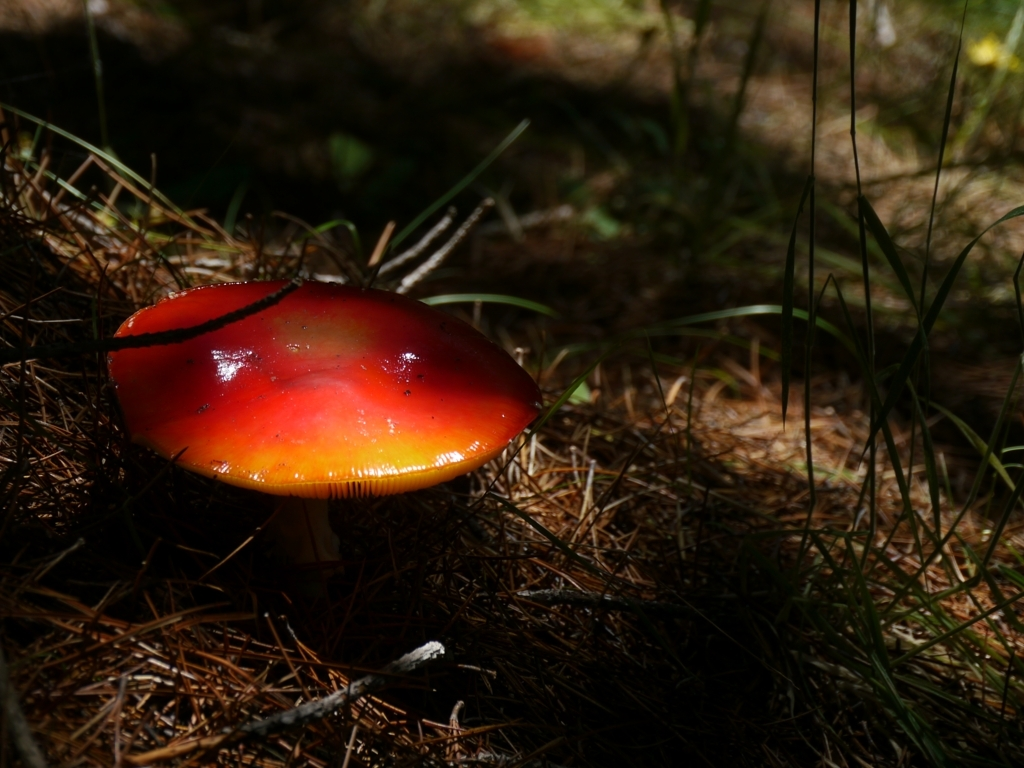Can you describe the habitat where this mushroom is growing? Certainly, the mushroom is growing in a natural, forested environment. It seems to be nestled on a bed of pine needles and organic debris, typical of coniferous forest floors. The presence of green grasses indicates that it might be near a clearing or a path. The environment looks fairly moist and shaded, which is ideal for many species of mushrooms to thrive. 